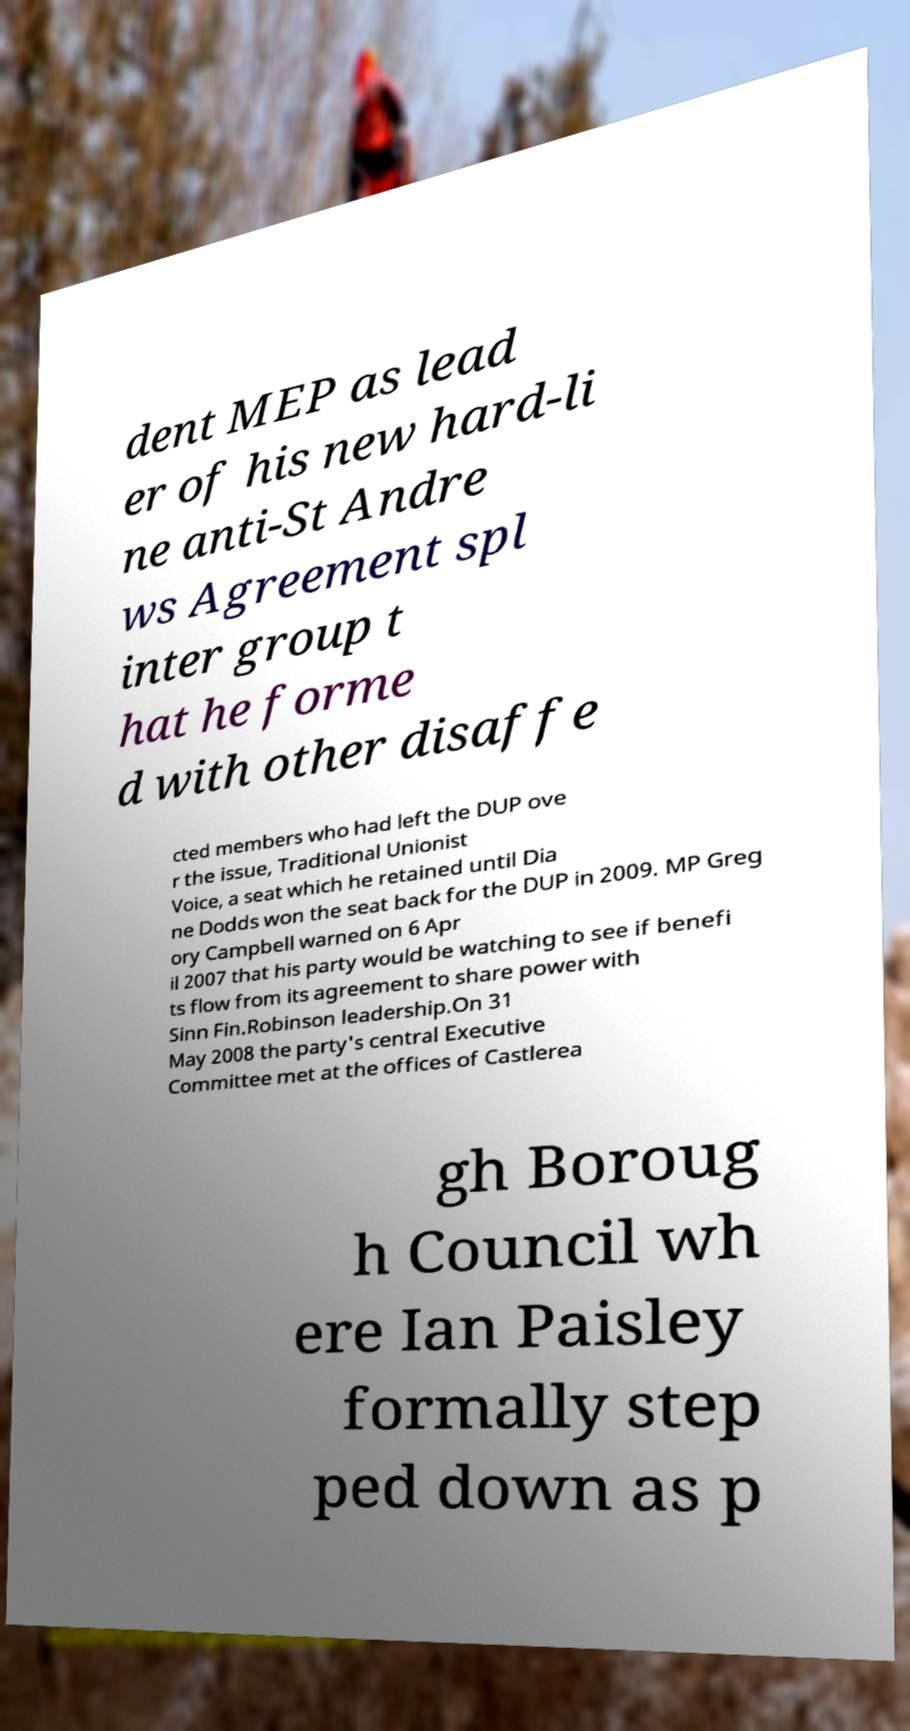Can you read and provide the text displayed in the image?This photo seems to have some interesting text. Can you extract and type it out for me? dent MEP as lead er of his new hard-li ne anti-St Andre ws Agreement spl inter group t hat he forme d with other disaffe cted members who had left the DUP ove r the issue, Traditional Unionist Voice, a seat which he retained until Dia ne Dodds won the seat back for the DUP in 2009. MP Greg ory Campbell warned on 6 Apr il 2007 that his party would be watching to see if benefi ts flow from its agreement to share power with Sinn Fin.Robinson leadership.On 31 May 2008 the party's central Executive Committee met at the offices of Castlerea gh Boroug h Council wh ere Ian Paisley formally step ped down as p 